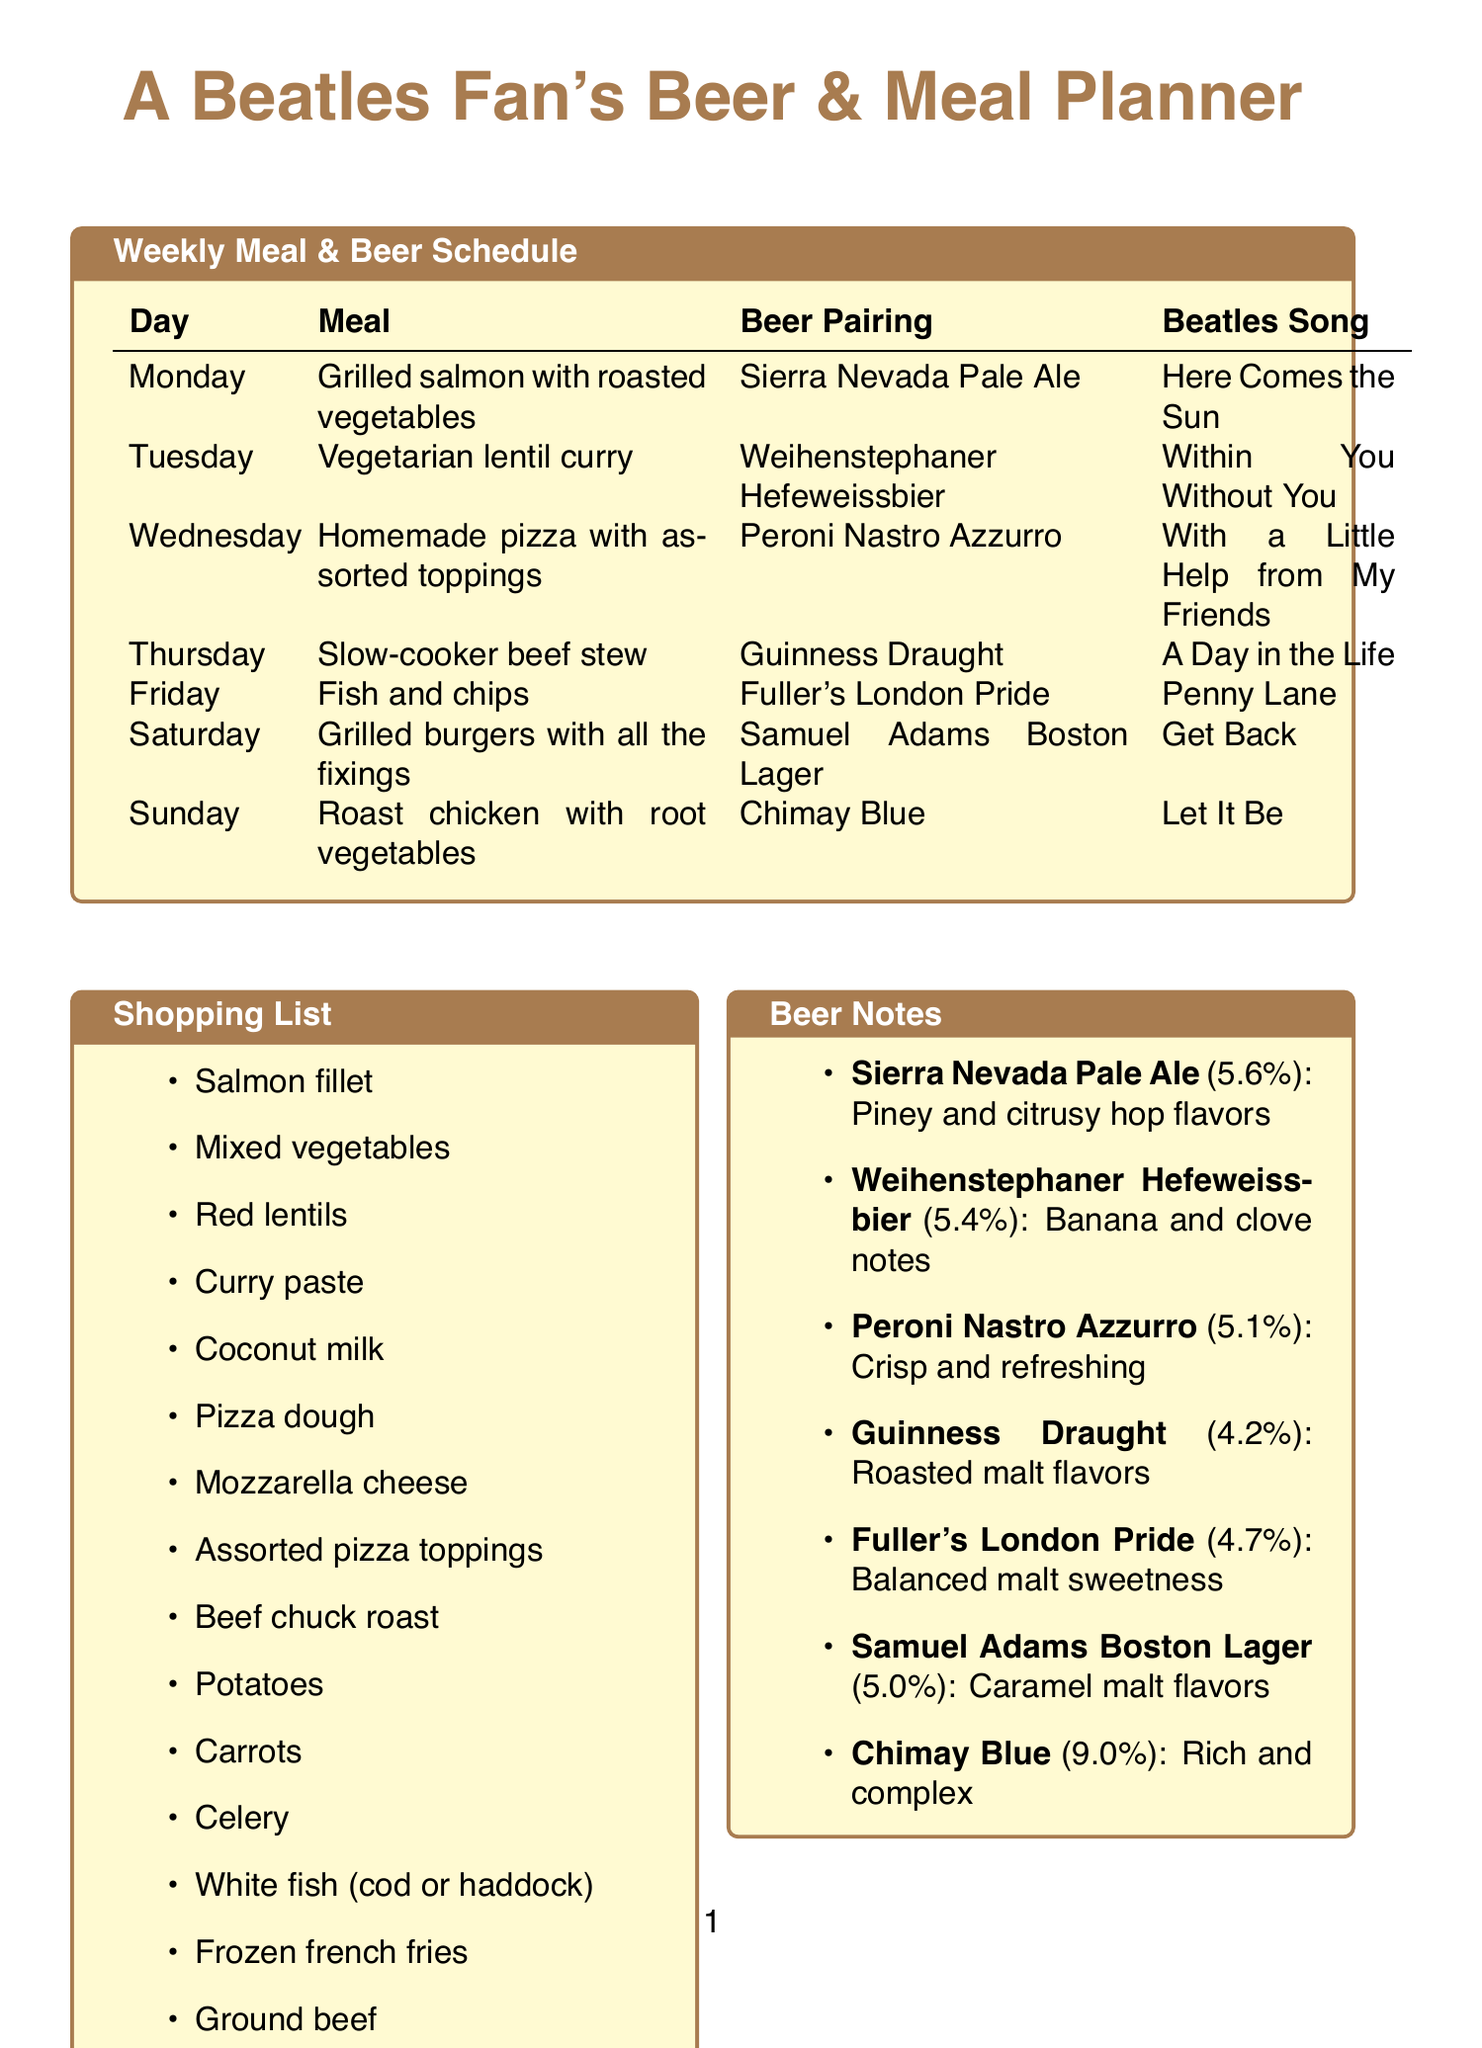What is the meal for Monday? The meal for Monday is listed in the schedule under that day.
Answer: Grilled salmon with roasted vegetables What beer pairs with Wednesday's meal? The beer pairing for Wednesday's meal can be found in the corresponding row of the schedule.
Answer: Peroni Nastro Azzurro What is the reason for pairing Sierra Nevada Pale Ale with grilled salmon? The reason is provided next to the beer pairing for grilled salmon in the schedule.
Answer: The hoppy bitterness complements the rich salmon flavor Which day is associated with "Let It Be"? The song is matched with the meal for Sunday in the document.
Answer: Sunday What is the ABV of Chimay Blue? The ABV value is listed under the beer notes section for Chimay Blue.
Answer: 9.0% What type of cuisine is the meal on Tuesday? The meal type can be determined from the meal provided for Tuesday in the schedule.
Answer: Vegetarian curry What is the key characteristic of Fuller's London Pride? The document lists key characteristics for each beer.
Answer: Balanced malt sweetness Which meal is paired with "Here Comes the Sun"? This pairing is associated with Monday's meal in the schedule.
Answer: Grilled salmon with roasted vegetables 